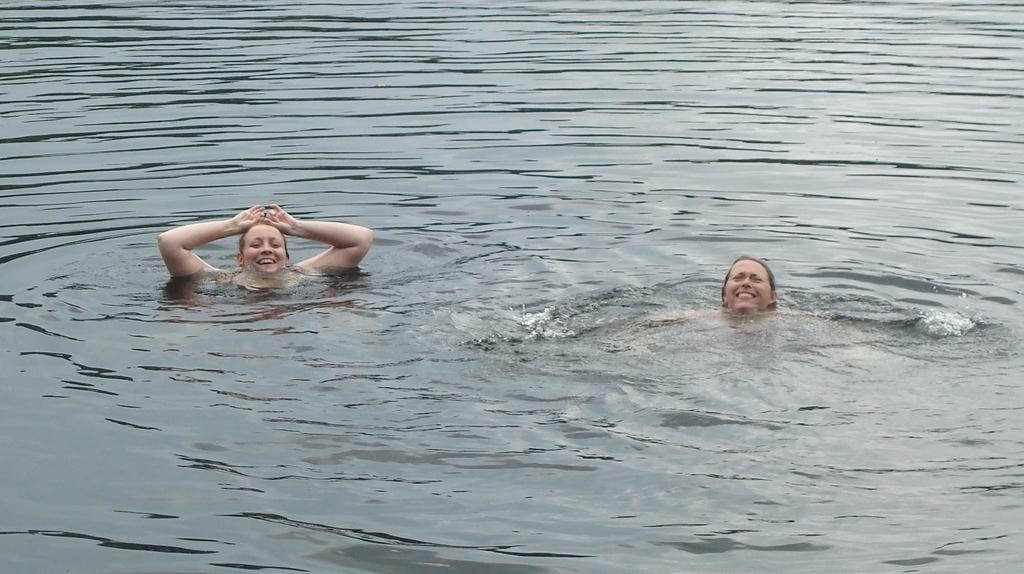How many people are in the image? There are two women in the image. What are the women doing in the image? The women are in the water. What is the facial expression of the women in the image? The women are smiling. What type of behavior can be observed in the women's hobbies in the image? There is no information about the women's hobbies or behavior in the image, as it only shows them smiling in the water. 